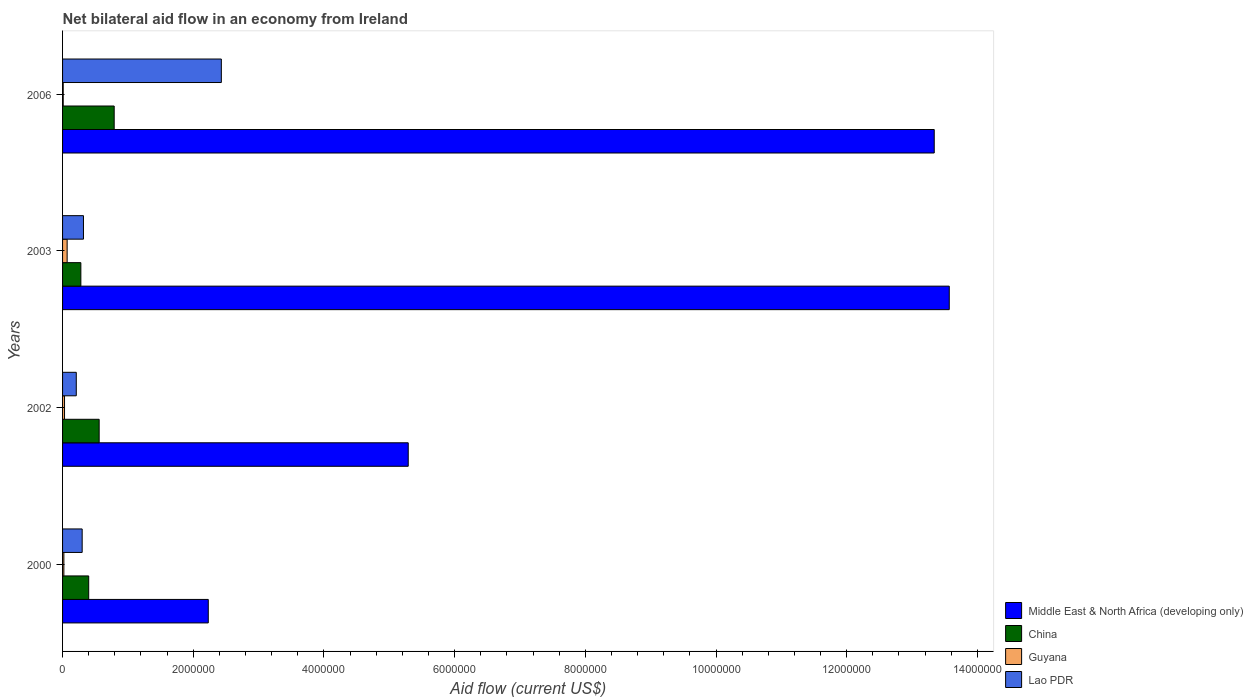How many groups of bars are there?
Ensure brevity in your answer.  4. How many bars are there on the 2nd tick from the top?
Keep it short and to the point. 4. How many bars are there on the 2nd tick from the bottom?
Your response must be concise. 4. Across all years, what is the minimum net bilateral aid flow in Middle East & North Africa (developing only)?
Your answer should be compact. 2.23e+06. In which year was the net bilateral aid flow in Guyana maximum?
Your answer should be compact. 2003. In which year was the net bilateral aid flow in China minimum?
Provide a short and direct response. 2003. What is the difference between the net bilateral aid flow in Guyana in 2003 and that in 2006?
Offer a very short reply. 6.00e+04. What is the difference between the net bilateral aid flow in Middle East & North Africa (developing only) in 2003 and the net bilateral aid flow in China in 2002?
Your response must be concise. 1.30e+07. What is the average net bilateral aid flow in Guyana per year?
Give a very brief answer. 3.25e+04. In the year 2006, what is the difference between the net bilateral aid flow in China and net bilateral aid flow in Guyana?
Your response must be concise. 7.80e+05. Is the net bilateral aid flow in Middle East & North Africa (developing only) in 2002 less than that in 2006?
Provide a short and direct response. Yes. What is the difference between the highest and the lowest net bilateral aid flow in China?
Give a very brief answer. 5.10e+05. In how many years, is the net bilateral aid flow in Guyana greater than the average net bilateral aid flow in Guyana taken over all years?
Make the answer very short. 1. Is the sum of the net bilateral aid flow in Guyana in 2000 and 2003 greater than the maximum net bilateral aid flow in Lao PDR across all years?
Make the answer very short. No. What does the 3rd bar from the bottom in 2006 represents?
Provide a short and direct response. Guyana. Is it the case that in every year, the sum of the net bilateral aid flow in China and net bilateral aid flow in Guyana is greater than the net bilateral aid flow in Middle East & North Africa (developing only)?
Offer a very short reply. No. How many bars are there?
Your answer should be very brief. 16. Are all the bars in the graph horizontal?
Provide a short and direct response. Yes. How many years are there in the graph?
Ensure brevity in your answer.  4. Are the values on the major ticks of X-axis written in scientific E-notation?
Keep it short and to the point. No. Does the graph contain any zero values?
Your answer should be compact. No. Does the graph contain grids?
Make the answer very short. No. Where does the legend appear in the graph?
Your answer should be very brief. Bottom right. How many legend labels are there?
Provide a succinct answer. 4. What is the title of the graph?
Ensure brevity in your answer.  Net bilateral aid flow in an economy from Ireland. What is the label or title of the Y-axis?
Your response must be concise. Years. What is the Aid flow (current US$) in Middle East & North Africa (developing only) in 2000?
Your answer should be very brief. 2.23e+06. What is the Aid flow (current US$) in Guyana in 2000?
Your response must be concise. 2.00e+04. What is the Aid flow (current US$) of Middle East & North Africa (developing only) in 2002?
Make the answer very short. 5.29e+06. What is the Aid flow (current US$) of China in 2002?
Your answer should be very brief. 5.60e+05. What is the Aid flow (current US$) in Lao PDR in 2002?
Your response must be concise. 2.10e+05. What is the Aid flow (current US$) of Middle East & North Africa (developing only) in 2003?
Offer a terse response. 1.36e+07. What is the Aid flow (current US$) in Middle East & North Africa (developing only) in 2006?
Keep it short and to the point. 1.33e+07. What is the Aid flow (current US$) in China in 2006?
Provide a succinct answer. 7.90e+05. What is the Aid flow (current US$) of Lao PDR in 2006?
Provide a succinct answer. 2.43e+06. Across all years, what is the maximum Aid flow (current US$) in Middle East & North Africa (developing only)?
Provide a short and direct response. 1.36e+07. Across all years, what is the maximum Aid flow (current US$) in China?
Provide a succinct answer. 7.90e+05. Across all years, what is the maximum Aid flow (current US$) in Lao PDR?
Offer a very short reply. 2.43e+06. Across all years, what is the minimum Aid flow (current US$) in Middle East & North Africa (developing only)?
Your answer should be compact. 2.23e+06. Across all years, what is the minimum Aid flow (current US$) in Lao PDR?
Offer a terse response. 2.10e+05. What is the total Aid flow (current US$) in Middle East & North Africa (developing only) in the graph?
Offer a terse response. 3.44e+07. What is the total Aid flow (current US$) of China in the graph?
Offer a very short reply. 2.03e+06. What is the total Aid flow (current US$) of Guyana in the graph?
Offer a terse response. 1.30e+05. What is the total Aid flow (current US$) in Lao PDR in the graph?
Provide a short and direct response. 3.26e+06. What is the difference between the Aid flow (current US$) of Middle East & North Africa (developing only) in 2000 and that in 2002?
Offer a very short reply. -3.06e+06. What is the difference between the Aid flow (current US$) of Guyana in 2000 and that in 2002?
Ensure brevity in your answer.  -10000. What is the difference between the Aid flow (current US$) of Middle East & North Africa (developing only) in 2000 and that in 2003?
Offer a very short reply. -1.13e+07. What is the difference between the Aid flow (current US$) of China in 2000 and that in 2003?
Provide a succinct answer. 1.20e+05. What is the difference between the Aid flow (current US$) of Lao PDR in 2000 and that in 2003?
Your response must be concise. -2.00e+04. What is the difference between the Aid flow (current US$) of Middle East & North Africa (developing only) in 2000 and that in 2006?
Give a very brief answer. -1.11e+07. What is the difference between the Aid flow (current US$) in China in 2000 and that in 2006?
Give a very brief answer. -3.90e+05. What is the difference between the Aid flow (current US$) of Guyana in 2000 and that in 2006?
Provide a succinct answer. 10000. What is the difference between the Aid flow (current US$) in Lao PDR in 2000 and that in 2006?
Provide a short and direct response. -2.13e+06. What is the difference between the Aid flow (current US$) of Middle East & North Africa (developing only) in 2002 and that in 2003?
Offer a very short reply. -8.28e+06. What is the difference between the Aid flow (current US$) of China in 2002 and that in 2003?
Offer a very short reply. 2.80e+05. What is the difference between the Aid flow (current US$) in Guyana in 2002 and that in 2003?
Offer a terse response. -4.00e+04. What is the difference between the Aid flow (current US$) of Middle East & North Africa (developing only) in 2002 and that in 2006?
Make the answer very short. -8.05e+06. What is the difference between the Aid flow (current US$) in Guyana in 2002 and that in 2006?
Offer a terse response. 2.00e+04. What is the difference between the Aid flow (current US$) in Lao PDR in 2002 and that in 2006?
Offer a very short reply. -2.22e+06. What is the difference between the Aid flow (current US$) of China in 2003 and that in 2006?
Your answer should be compact. -5.10e+05. What is the difference between the Aid flow (current US$) in Guyana in 2003 and that in 2006?
Keep it short and to the point. 6.00e+04. What is the difference between the Aid flow (current US$) of Lao PDR in 2003 and that in 2006?
Your answer should be compact. -2.11e+06. What is the difference between the Aid flow (current US$) of Middle East & North Africa (developing only) in 2000 and the Aid flow (current US$) of China in 2002?
Your response must be concise. 1.67e+06. What is the difference between the Aid flow (current US$) in Middle East & North Africa (developing only) in 2000 and the Aid flow (current US$) in Guyana in 2002?
Keep it short and to the point. 2.20e+06. What is the difference between the Aid flow (current US$) in Middle East & North Africa (developing only) in 2000 and the Aid flow (current US$) in Lao PDR in 2002?
Your answer should be very brief. 2.02e+06. What is the difference between the Aid flow (current US$) of China in 2000 and the Aid flow (current US$) of Guyana in 2002?
Provide a short and direct response. 3.70e+05. What is the difference between the Aid flow (current US$) of China in 2000 and the Aid flow (current US$) of Lao PDR in 2002?
Provide a succinct answer. 1.90e+05. What is the difference between the Aid flow (current US$) in Guyana in 2000 and the Aid flow (current US$) in Lao PDR in 2002?
Provide a succinct answer. -1.90e+05. What is the difference between the Aid flow (current US$) in Middle East & North Africa (developing only) in 2000 and the Aid flow (current US$) in China in 2003?
Your response must be concise. 1.95e+06. What is the difference between the Aid flow (current US$) of Middle East & North Africa (developing only) in 2000 and the Aid flow (current US$) of Guyana in 2003?
Keep it short and to the point. 2.16e+06. What is the difference between the Aid flow (current US$) in Middle East & North Africa (developing only) in 2000 and the Aid flow (current US$) in Lao PDR in 2003?
Your answer should be compact. 1.91e+06. What is the difference between the Aid flow (current US$) in China in 2000 and the Aid flow (current US$) in Lao PDR in 2003?
Make the answer very short. 8.00e+04. What is the difference between the Aid flow (current US$) of Middle East & North Africa (developing only) in 2000 and the Aid flow (current US$) of China in 2006?
Offer a very short reply. 1.44e+06. What is the difference between the Aid flow (current US$) of Middle East & North Africa (developing only) in 2000 and the Aid flow (current US$) of Guyana in 2006?
Give a very brief answer. 2.22e+06. What is the difference between the Aid flow (current US$) in Middle East & North Africa (developing only) in 2000 and the Aid flow (current US$) in Lao PDR in 2006?
Your answer should be very brief. -2.00e+05. What is the difference between the Aid flow (current US$) in China in 2000 and the Aid flow (current US$) in Guyana in 2006?
Give a very brief answer. 3.90e+05. What is the difference between the Aid flow (current US$) in China in 2000 and the Aid flow (current US$) in Lao PDR in 2006?
Offer a terse response. -2.03e+06. What is the difference between the Aid flow (current US$) in Guyana in 2000 and the Aid flow (current US$) in Lao PDR in 2006?
Your response must be concise. -2.41e+06. What is the difference between the Aid flow (current US$) in Middle East & North Africa (developing only) in 2002 and the Aid flow (current US$) in China in 2003?
Your response must be concise. 5.01e+06. What is the difference between the Aid flow (current US$) in Middle East & North Africa (developing only) in 2002 and the Aid flow (current US$) in Guyana in 2003?
Offer a terse response. 5.22e+06. What is the difference between the Aid flow (current US$) in Middle East & North Africa (developing only) in 2002 and the Aid flow (current US$) in Lao PDR in 2003?
Keep it short and to the point. 4.97e+06. What is the difference between the Aid flow (current US$) of Middle East & North Africa (developing only) in 2002 and the Aid flow (current US$) of China in 2006?
Offer a very short reply. 4.50e+06. What is the difference between the Aid flow (current US$) of Middle East & North Africa (developing only) in 2002 and the Aid flow (current US$) of Guyana in 2006?
Your answer should be compact. 5.28e+06. What is the difference between the Aid flow (current US$) in Middle East & North Africa (developing only) in 2002 and the Aid flow (current US$) in Lao PDR in 2006?
Provide a succinct answer. 2.86e+06. What is the difference between the Aid flow (current US$) of China in 2002 and the Aid flow (current US$) of Lao PDR in 2006?
Make the answer very short. -1.87e+06. What is the difference between the Aid flow (current US$) in Guyana in 2002 and the Aid flow (current US$) in Lao PDR in 2006?
Offer a very short reply. -2.40e+06. What is the difference between the Aid flow (current US$) in Middle East & North Africa (developing only) in 2003 and the Aid flow (current US$) in China in 2006?
Your answer should be very brief. 1.28e+07. What is the difference between the Aid flow (current US$) of Middle East & North Africa (developing only) in 2003 and the Aid flow (current US$) of Guyana in 2006?
Your response must be concise. 1.36e+07. What is the difference between the Aid flow (current US$) in Middle East & North Africa (developing only) in 2003 and the Aid flow (current US$) in Lao PDR in 2006?
Keep it short and to the point. 1.11e+07. What is the difference between the Aid flow (current US$) of China in 2003 and the Aid flow (current US$) of Guyana in 2006?
Keep it short and to the point. 2.70e+05. What is the difference between the Aid flow (current US$) in China in 2003 and the Aid flow (current US$) in Lao PDR in 2006?
Keep it short and to the point. -2.15e+06. What is the difference between the Aid flow (current US$) of Guyana in 2003 and the Aid flow (current US$) of Lao PDR in 2006?
Offer a very short reply. -2.36e+06. What is the average Aid flow (current US$) in Middle East & North Africa (developing only) per year?
Provide a succinct answer. 8.61e+06. What is the average Aid flow (current US$) in China per year?
Your response must be concise. 5.08e+05. What is the average Aid flow (current US$) in Guyana per year?
Provide a succinct answer. 3.25e+04. What is the average Aid flow (current US$) in Lao PDR per year?
Your response must be concise. 8.15e+05. In the year 2000, what is the difference between the Aid flow (current US$) in Middle East & North Africa (developing only) and Aid flow (current US$) in China?
Ensure brevity in your answer.  1.83e+06. In the year 2000, what is the difference between the Aid flow (current US$) of Middle East & North Africa (developing only) and Aid flow (current US$) of Guyana?
Your answer should be very brief. 2.21e+06. In the year 2000, what is the difference between the Aid flow (current US$) in Middle East & North Africa (developing only) and Aid flow (current US$) in Lao PDR?
Provide a succinct answer. 1.93e+06. In the year 2000, what is the difference between the Aid flow (current US$) in China and Aid flow (current US$) in Lao PDR?
Give a very brief answer. 1.00e+05. In the year 2000, what is the difference between the Aid flow (current US$) in Guyana and Aid flow (current US$) in Lao PDR?
Offer a terse response. -2.80e+05. In the year 2002, what is the difference between the Aid flow (current US$) of Middle East & North Africa (developing only) and Aid flow (current US$) of China?
Your answer should be very brief. 4.73e+06. In the year 2002, what is the difference between the Aid flow (current US$) of Middle East & North Africa (developing only) and Aid flow (current US$) of Guyana?
Make the answer very short. 5.26e+06. In the year 2002, what is the difference between the Aid flow (current US$) in Middle East & North Africa (developing only) and Aid flow (current US$) in Lao PDR?
Provide a short and direct response. 5.08e+06. In the year 2002, what is the difference between the Aid flow (current US$) of China and Aid flow (current US$) of Guyana?
Keep it short and to the point. 5.30e+05. In the year 2002, what is the difference between the Aid flow (current US$) of China and Aid flow (current US$) of Lao PDR?
Provide a succinct answer. 3.50e+05. In the year 2002, what is the difference between the Aid flow (current US$) in Guyana and Aid flow (current US$) in Lao PDR?
Your answer should be very brief. -1.80e+05. In the year 2003, what is the difference between the Aid flow (current US$) of Middle East & North Africa (developing only) and Aid flow (current US$) of China?
Your answer should be very brief. 1.33e+07. In the year 2003, what is the difference between the Aid flow (current US$) in Middle East & North Africa (developing only) and Aid flow (current US$) in Guyana?
Give a very brief answer. 1.35e+07. In the year 2003, what is the difference between the Aid flow (current US$) in Middle East & North Africa (developing only) and Aid flow (current US$) in Lao PDR?
Offer a terse response. 1.32e+07. In the year 2003, what is the difference between the Aid flow (current US$) of China and Aid flow (current US$) of Guyana?
Offer a terse response. 2.10e+05. In the year 2003, what is the difference between the Aid flow (current US$) in Guyana and Aid flow (current US$) in Lao PDR?
Your answer should be very brief. -2.50e+05. In the year 2006, what is the difference between the Aid flow (current US$) in Middle East & North Africa (developing only) and Aid flow (current US$) in China?
Provide a short and direct response. 1.26e+07. In the year 2006, what is the difference between the Aid flow (current US$) of Middle East & North Africa (developing only) and Aid flow (current US$) of Guyana?
Your answer should be compact. 1.33e+07. In the year 2006, what is the difference between the Aid flow (current US$) in Middle East & North Africa (developing only) and Aid flow (current US$) in Lao PDR?
Provide a succinct answer. 1.09e+07. In the year 2006, what is the difference between the Aid flow (current US$) in China and Aid flow (current US$) in Guyana?
Ensure brevity in your answer.  7.80e+05. In the year 2006, what is the difference between the Aid flow (current US$) of China and Aid flow (current US$) of Lao PDR?
Provide a short and direct response. -1.64e+06. In the year 2006, what is the difference between the Aid flow (current US$) of Guyana and Aid flow (current US$) of Lao PDR?
Ensure brevity in your answer.  -2.42e+06. What is the ratio of the Aid flow (current US$) of Middle East & North Africa (developing only) in 2000 to that in 2002?
Give a very brief answer. 0.42. What is the ratio of the Aid flow (current US$) in China in 2000 to that in 2002?
Give a very brief answer. 0.71. What is the ratio of the Aid flow (current US$) in Guyana in 2000 to that in 2002?
Keep it short and to the point. 0.67. What is the ratio of the Aid flow (current US$) in Lao PDR in 2000 to that in 2002?
Your response must be concise. 1.43. What is the ratio of the Aid flow (current US$) in Middle East & North Africa (developing only) in 2000 to that in 2003?
Keep it short and to the point. 0.16. What is the ratio of the Aid flow (current US$) in China in 2000 to that in 2003?
Give a very brief answer. 1.43. What is the ratio of the Aid flow (current US$) in Guyana in 2000 to that in 2003?
Your response must be concise. 0.29. What is the ratio of the Aid flow (current US$) in Lao PDR in 2000 to that in 2003?
Your response must be concise. 0.94. What is the ratio of the Aid flow (current US$) in Middle East & North Africa (developing only) in 2000 to that in 2006?
Your response must be concise. 0.17. What is the ratio of the Aid flow (current US$) of China in 2000 to that in 2006?
Your answer should be compact. 0.51. What is the ratio of the Aid flow (current US$) in Lao PDR in 2000 to that in 2006?
Give a very brief answer. 0.12. What is the ratio of the Aid flow (current US$) in Middle East & North Africa (developing only) in 2002 to that in 2003?
Your answer should be compact. 0.39. What is the ratio of the Aid flow (current US$) of China in 2002 to that in 2003?
Give a very brief answer. 2. What is the ratio of the Aid flow (current US$) of Guyana in 2002 to that in 2003?
Your answer should be very brief. 0.43. What is the ratio of the Aid flow (current US$) of Lao PDR in 2002 to that in 2003?
Make the answer very short. 0.66. What is the ratio of the Aid flow (current US$) in Middle East & North Africa (developing only) in 2002 to that in 2006?
Keep it short and to the point. 0.4. What is the ratio of the Aid flow (current US$) in China in 2002 to that in 2006?
Your answer should be very brief. 0.71. What is the ratio of the Aid flow (current US$) in Lao PDR in 2002 to that in 2006?
Your answer should be compact. 0.09. What is the ratio of the Aid flow (current US$) in Middle East & North Africa (developing only) in 2003 to that in 2006?
Make the answer very short. 1.02. What is the ratio of the Aid flow (current US$) of China in 2003 to that in 2006?
Ensure brevity in your answer.  0.35. What is the ratio of the Aid flow (current US$) in Guyana in 2003 to that in 2006?
Make the answer very short. 7. What is the ratio of the Aid flow (current US$) in Lao PDR in 2003 to that in 2006?
Keep it short and to the point. 0.13. What is the difference between the highest and the second highest Aid flow (current US$) in Guyana?
Offer a terse response. 4.00e+04. What is the difference between the highest and the second highest Aid flow (current US$) in Lao PDR?
Your answer should be compact. 2.11e+06. What is the difference between the highest and the lowest Aid flow (current US$) of Middle East & North Africa (developing only)?
Ensure brevity in your answer.  1.13e+07. What is the difference between the highest and the lowest Aid flow (current US$) in China?
Offer a terse response. 5.10e+05. What is the difference between the highest and the lowest Aid flow (current US$) in Guyana?
Offer a very short reply. 6.00e+04. What is the difference between the highest and the lowest Aid flow (current US$) of Lao PDR?
Ensure brevity in your answer.  2.22e+06. 